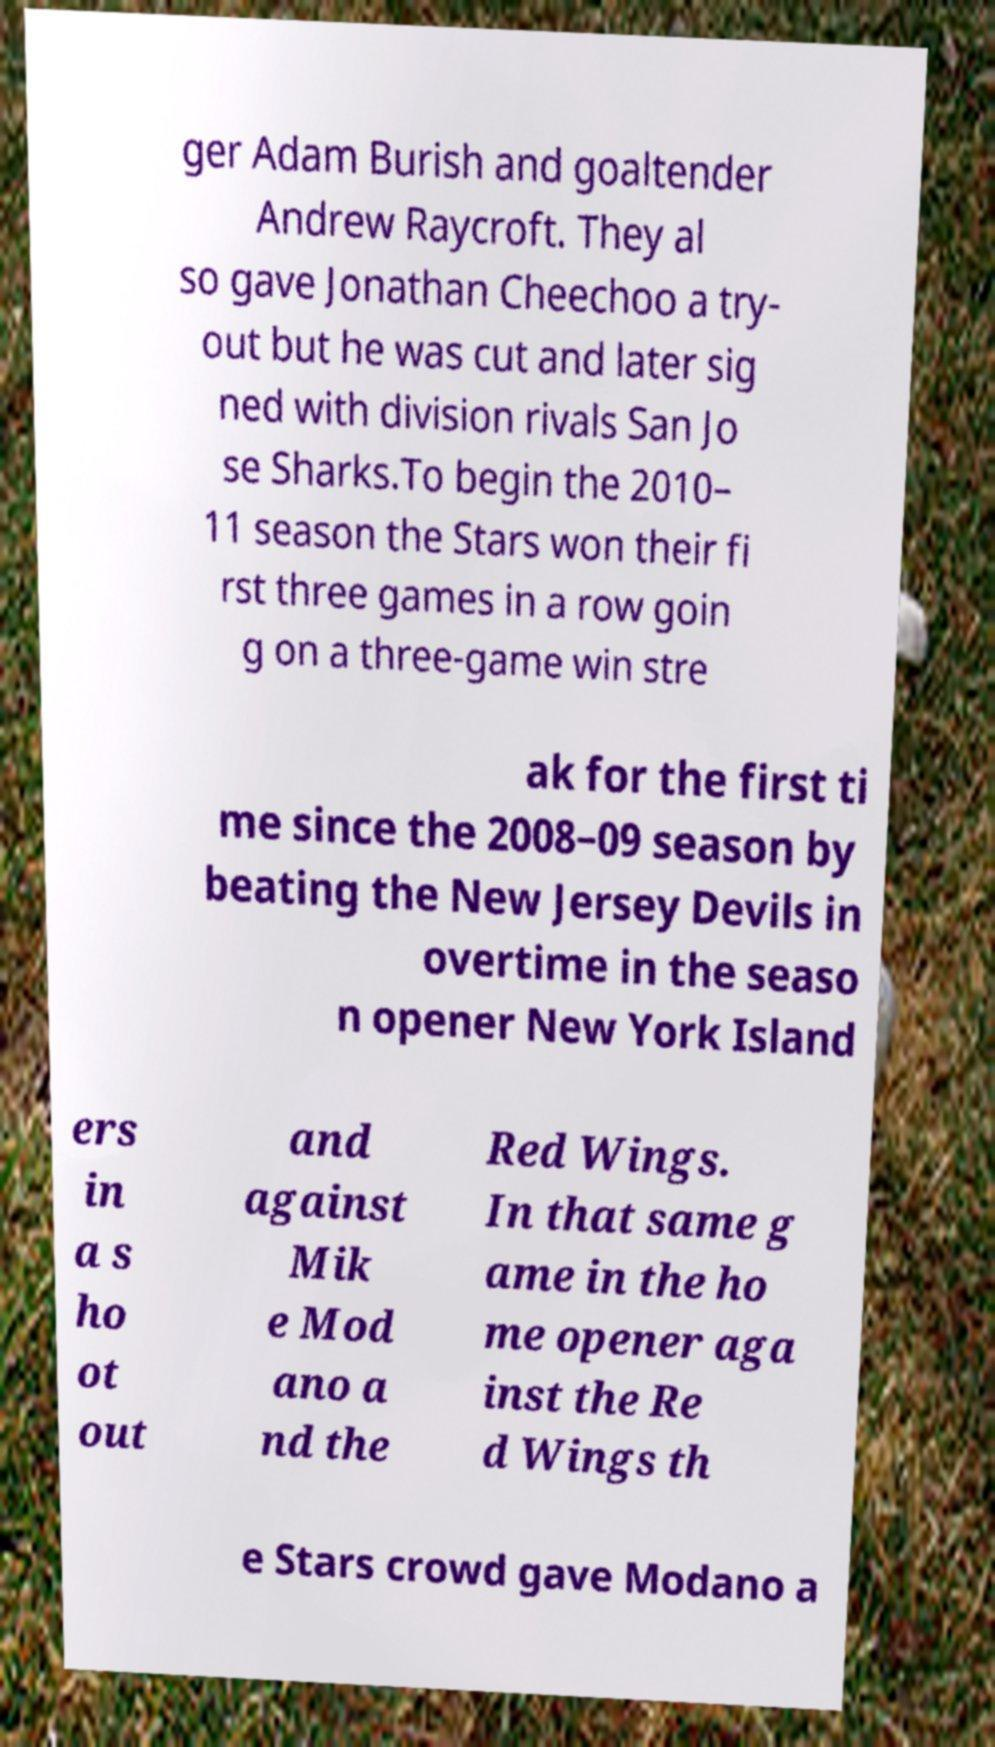I need the written content from this picture converted into text. Can you do that? ger Adam Burish and goaltender Andrew Raycroft. They al so gave Jonathan Cheechoo a try- out but he was cut and later sig ned with division rivals San Jo se Sharks.To begin the 2010– 11 season the Stars won their fi rst three games in a row goin g on a three-game win stre ak for the first ti me since the 2008–09 season by beating the New Jersey Devils in overtime in the seaso n opener New York Island ers in a s ho ot out and against Mik e Mod ano a nd the Red Wings. In that same g ame in the ho me opener aga inst the Re d Wings th e Stars crowd gave Modano a 